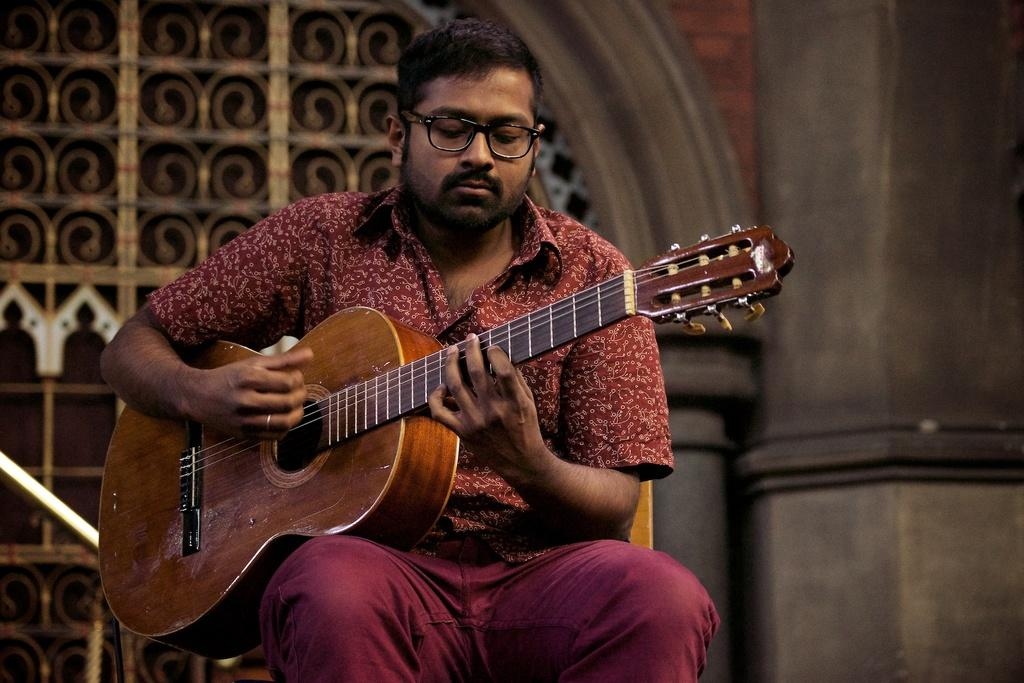Who is the main subject in the image? There is a man in the image. What is the man wearing? The man is wearing a brown dress. What object is the man holding? The man is holding a guitar. What is the man doing with the guitar? The man is playing the guitar. Can you hear the noise of the lake in the background of the image? There is no lake or any noise mentioned in the image; it only features a man playing a guitar. 